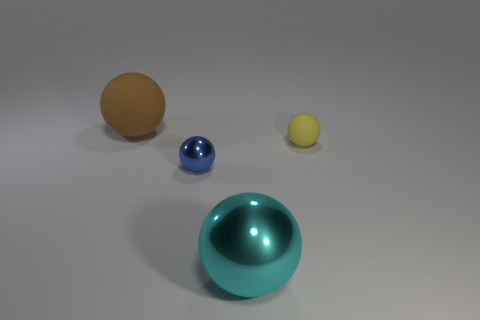Does the cyan thing have the same material as the tiny blue ball?
Offer a very short reply. Yes. The yellow thing that is the same shape as the blue metal thing is what size?
Provide a succinct answer. Small. Do the cyan thing and the object that is on the left side of the small metal sphere have the same size?
Your answer should be compact. Yes. What number of other things are made of the same material as the brown thing?
Provide a short and direct response. 1. What is the color of the ball that is behind the rubber ball that is in front of the big sphere that is to the left of the tiny blue ball?
Your response must be concise. Brown. There is a object that is on the right side of the blue sphere and behind the big cyan shiny sphere; what is its shape?
Offer a very short reply. Sphere. There is a big sphere behind the rubber ball that is on the right side of the tiny shiny thing; what is its color?
Your response must be concise. Brown. There is a sphere that is right of the tiny blue metallic object and in front of the yellow sphere; what is its size?
Ensure brevity in your answer.  Large. How many small shiny balls have the same color as the large metal thing?
Keep it short and to the point. 0. What is the small yellow object made of?
Provide a short and direct response. Rubber. 